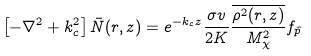<formula> <loc_0><loc_0><loc_500><loc_500>\left [ - \nabla ^ { 2 } + k _ { c } ^ { 2 } \right ] \bar { N } ( r , z ) = e ^ { - k _ { c } z } \frac { \sigma v } { 2 K } \frac { \overline { \rho ^ { 2 } ( r , z ) } } { M _ { \chi } ^ { 2 } } f _ { \bar { p } }</formula> 